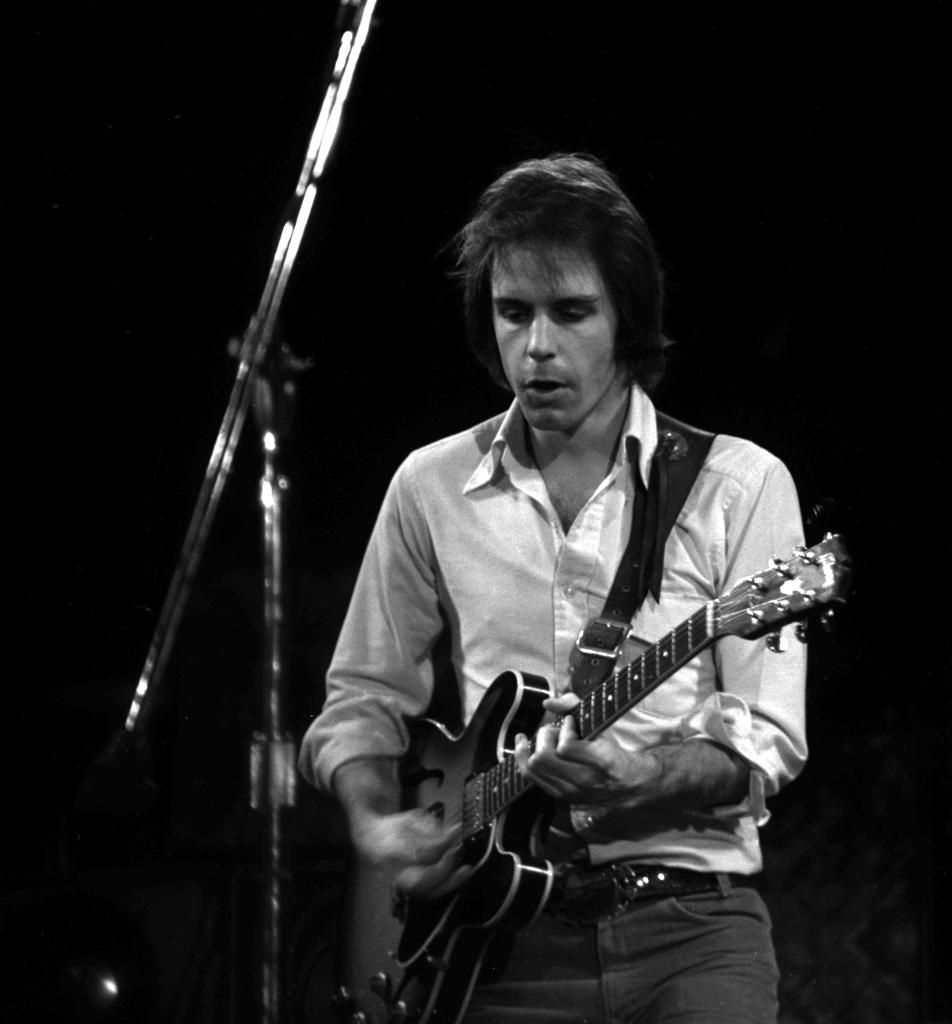What is the main subject of the picture? The main subject of the picture is a man. What is the man doing in the picture? The man is standing, holding a guitar, and singing a song. How is the man singing the song? The man is using a microphone to sing. What type of cord is attached to the guitar in the image? There is no cord attached to the guitar in the image. What is the man using to stop the song in the image? The man is not shown stopping the song in the image; he is actively singing with a microphone. 